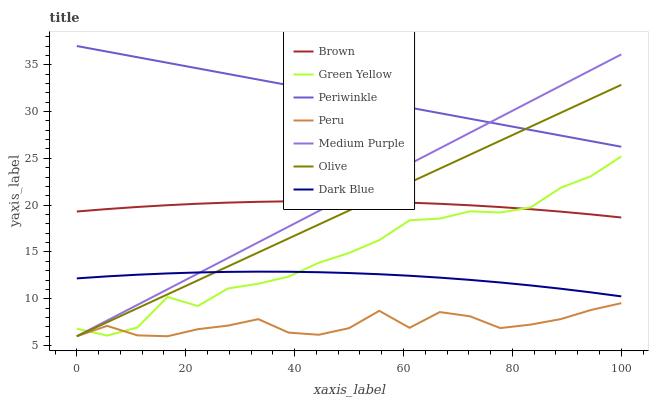Does Peru have the minimum area under the curve?
Answer yes or no. Yes. Does Periwinkle have the maximum area under the curve?
Answer yes or no. Yes. Does Medium Purple have the minimum area under the curve?
Answer yes or no. No. Does Medium Purple have the maximum area under the curve?
Answer yes or no. No. Is Medium Purple the smoothest?
Answer yes or no. Yes. Is Peru the roughest?
Answer yes or no. Yes. Is Dark Blue the smoothest?
Answer yes or no. No. Is Dark Blue the roughest?
Answer yes or no. No. Does Medium Purple have the lowest value?
Answer yes or no. Yes. Does Dark Blue have the lowest value?
Answer yes or no. No. Does Periwinkle have the highest value?
Answer yes or no. Yes. Does Medium Purple have the highest value?
Answer yes or no. No. Is Brown less than Periwinkle?
Answer yes or no. Yes. Is Dark Blue greater than Peru?
Answer yes or no. Yes. Does Periwinkle intersect Olive?
Answer yes or no. Yes. Is Periwinkle less than Olive?
Answer yes or no. No. Is Periwinkle greater than Olive?
Answer yes or no. No. Does Brown intersect Periwinkle?
Answer yes or no. No. 